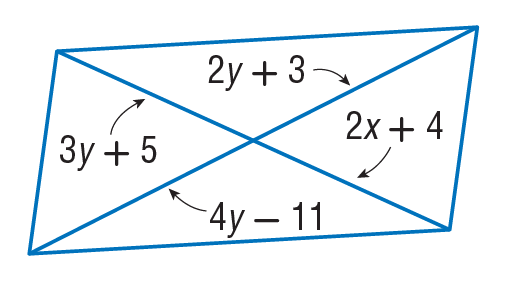Answer the mathemtical geometry problem and directly provide the correct option letter.
Question: Find x so that the quadrilateral is a parallelogram.
Choices: A: 11 B: 25 C: 26 D: 33 A 